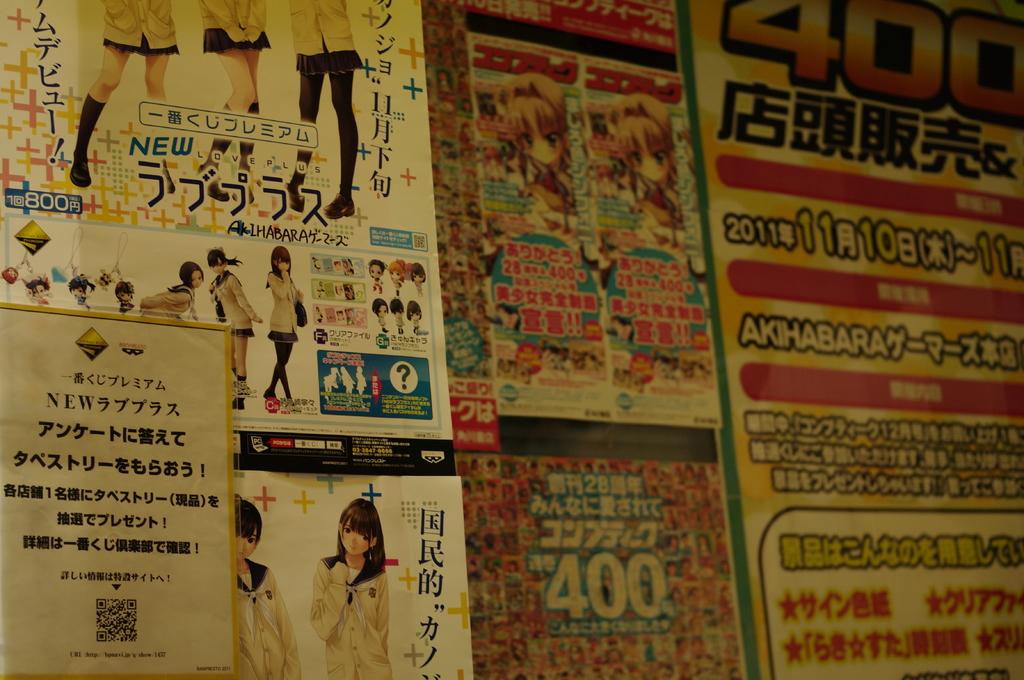What number is written on the top right?
Offer a terse response. 400. 